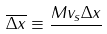Convert formula to latex. <formula><loc_0><loc_0><loc_500><loc_500>\overline { \Delta x } \equiv \frac { M v _ { s } \Delta x } { }</formula> 